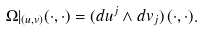Convert formula to latex. <formula><loc_0><loc_0><loc_500><loc_500>\Omega | _ { ( u , v ) } ( \cdot , \cdot ) = ( d u ^ { j } \wedge d v _ { j } ) \, ( \cdot , \cdot ) .</formula> 